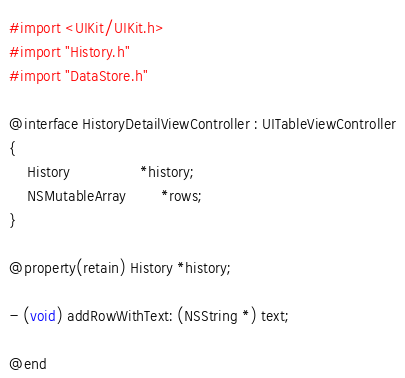<code> <loc_0><loc_0><loc_500><loc_500><_C_>#import <UIKit/UIKit.h>
#import "History.h"
#import "DataStore.h"

@interface HistoryDetailViewController : UITableViewController
{
	History				*history;
	NSMutableArray		*rows;
}

@property(retain) History *history;

- (void) addRowWithText: (NSString *) text;

@end</code> 